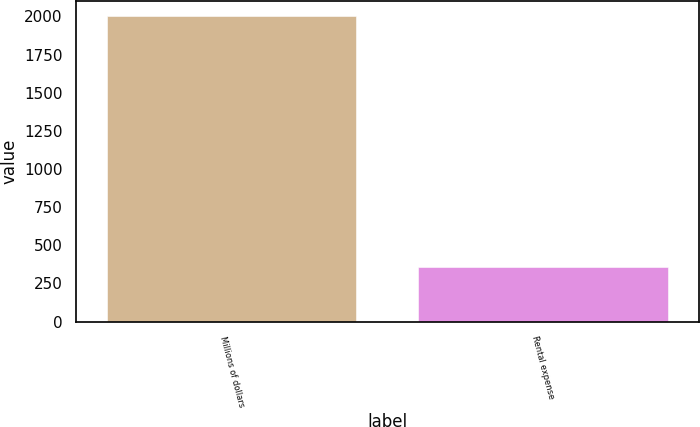<chart> <loc_0><loc_0><loc_500><loc_500><bar_chart><fcel>Millions of dollars<fcel>Rental expense<nl><fcel>2002<fcel>356<nl></chart> 